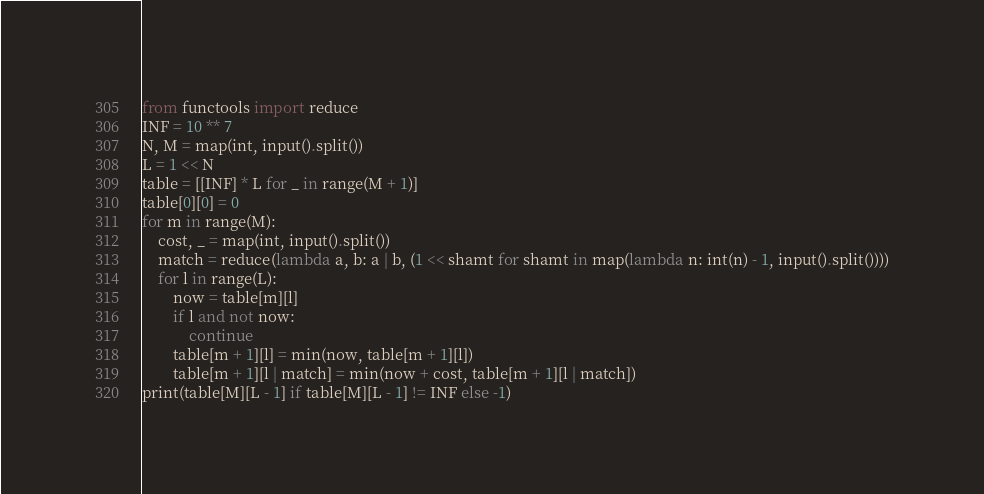<code> <loc_0><loc_0><loc_500><loc_500><_Python_>from functools import reduce
INF = 10 ** 7
N, M = map(int, input().split())
L = 1 << N
table = [[INF] * L for _ in range(M + 1)]
table[0][0] = 0
for m in range(M):
    cost, _ = map(int, input().split())
    match = reduce(lambda a, b: a | b, (1 << shamt for shamt in map(lambda n: int(n) - 1, input().split())))
    for l in range(L):
        now = table[m][l]
        if l and not now:
            continue
        table[m + 1][l] = min(now, table[m + 1][l])
        table[m + 1][l | match] = min(now + cost, table[m + 1][l | match])
print(table[M][L - 1] if table[M][L - 1] != INF else -1)</code> 